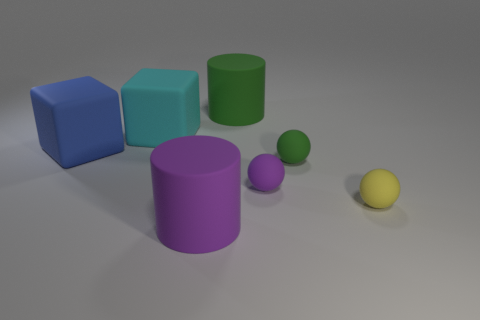What shape is the purple object that is in front of the tiny sphere that is right of the tiny green ball?
Give a very brief answer. Cylinder. What number of large purple things are made of the same material as the large cyan object?
Keep it short and to the point. 1. The green object that is in front of the rubber thing on the left side of the cube that is behind the large blue rubber object is what shape?
Offer a very short reply. Sphere. There is a matte cylinder that is in front of the big green object; is it the same color as the rubber cylinder that is behind the small green object?
Offer a very short reply. No. Are there fewer small yellow rubber objects to the right of the yellow sphere than large green things that are to the right of the purple rubber sphere?
Your answer should be very brief. No. Are there any other things that are the same shape as the tiny green thing?
Offer a terse response. Yes. What color is the other large thing that is the same shape as the large green matte thing?
Provide a short and direct response. Purple. There is a blue rubber thing; is its shape the same as the small matte thing that is on the right side of the small green rubber sphere?
Offer a terse response. No. How many objects are either large things behind the blue matte thing or objects that are on the left side of the purple matte cylinder?
Give a very brief answer. 3. What material is the purple sphere?
Ensure brevity in your answer.  Rubber. 